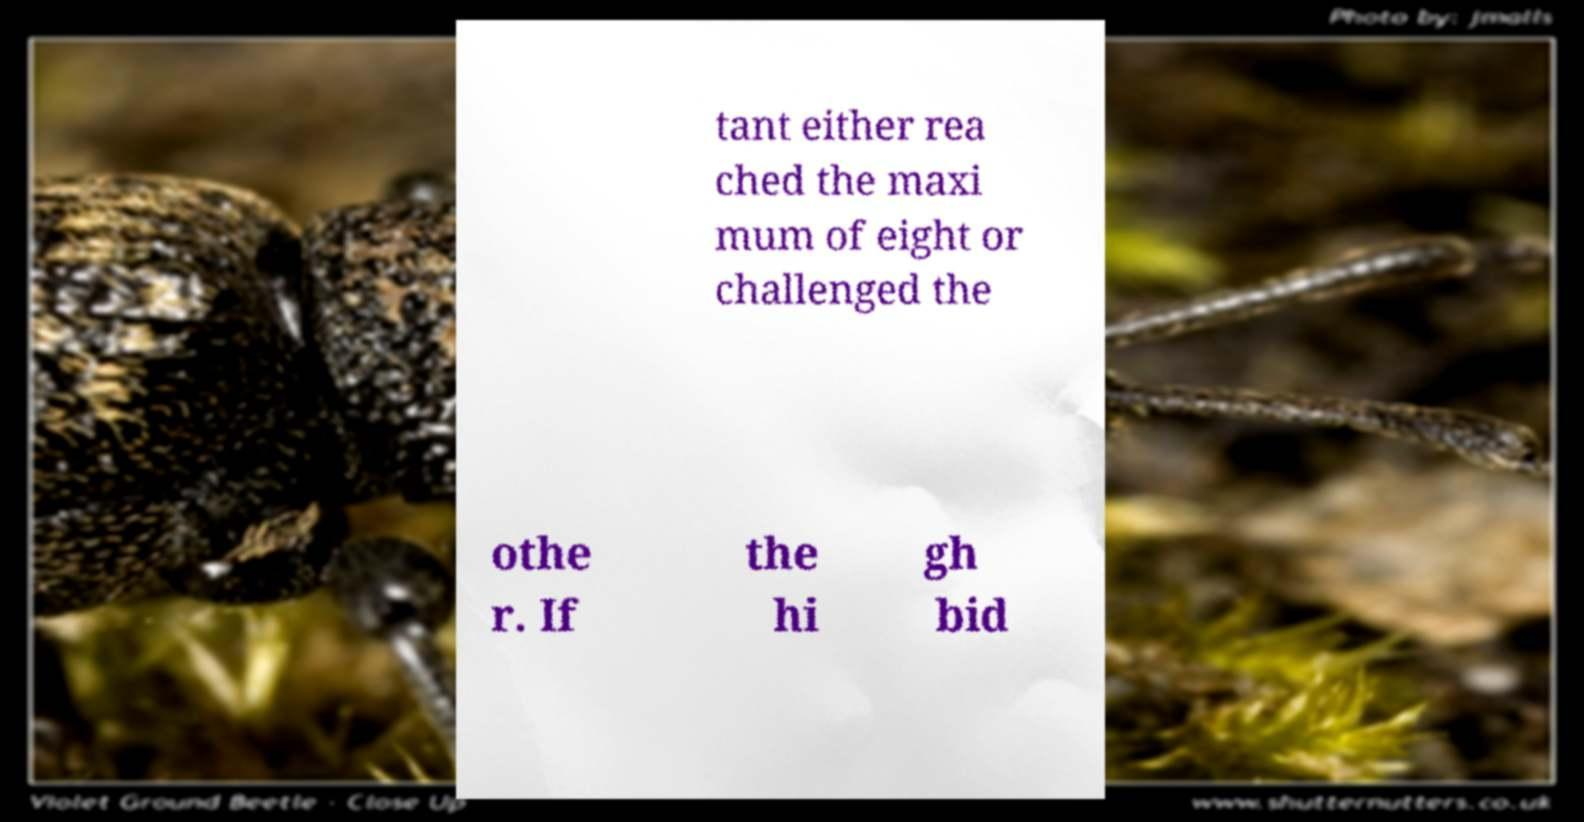There's text embedded in this image that I need extracted. Can you transcribe it verbatim? tant either rea ched the maxi mum of eight or challenged the othe r. If the hi gh bid 